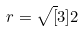Convert formula to latex. <formula><loc_0><loc_0><loc_500><loc_500>r = \sqrt { [ } 3 ] { 2 }</formula> 